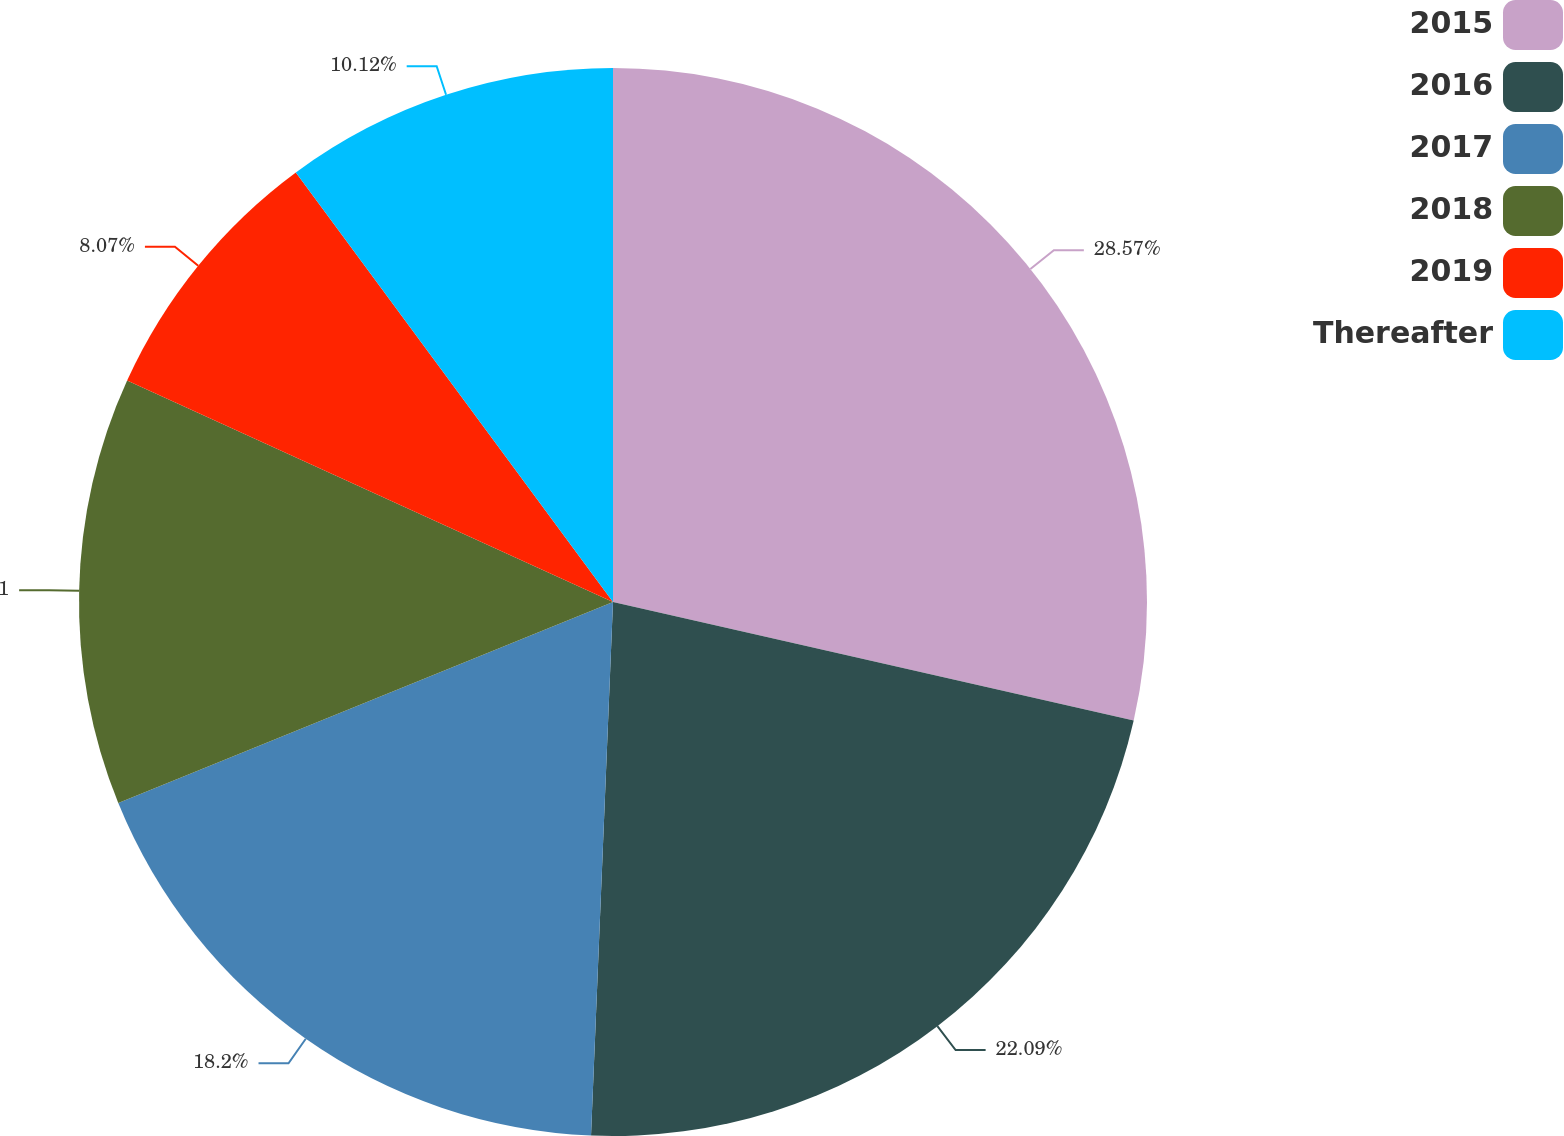Convert chart to OTSL. <chart><loc_0><loc_0><loc_500><loc_500><pie_chart><fcel>2015<fcel>2016<fcel>2017<fcel>2018<fcel>2019<fcel>Thereafter<nl><fcel>28.56%<fcel>22.09%<fcel>18.2%<fcel>12.95%<fcel>8.07%<fcel>10.12%<nl></chart> 